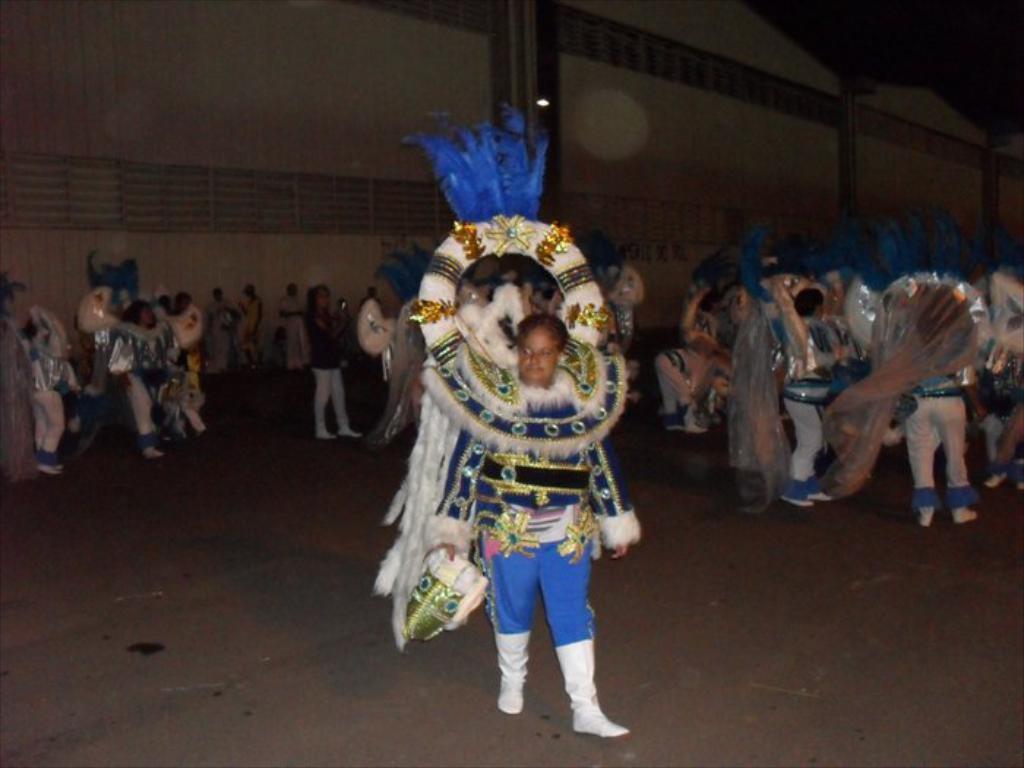Please provide a concise description of this image. In this image I see number of people in which most of them are wearing costumes and I see the path. In the background I see the wall. 